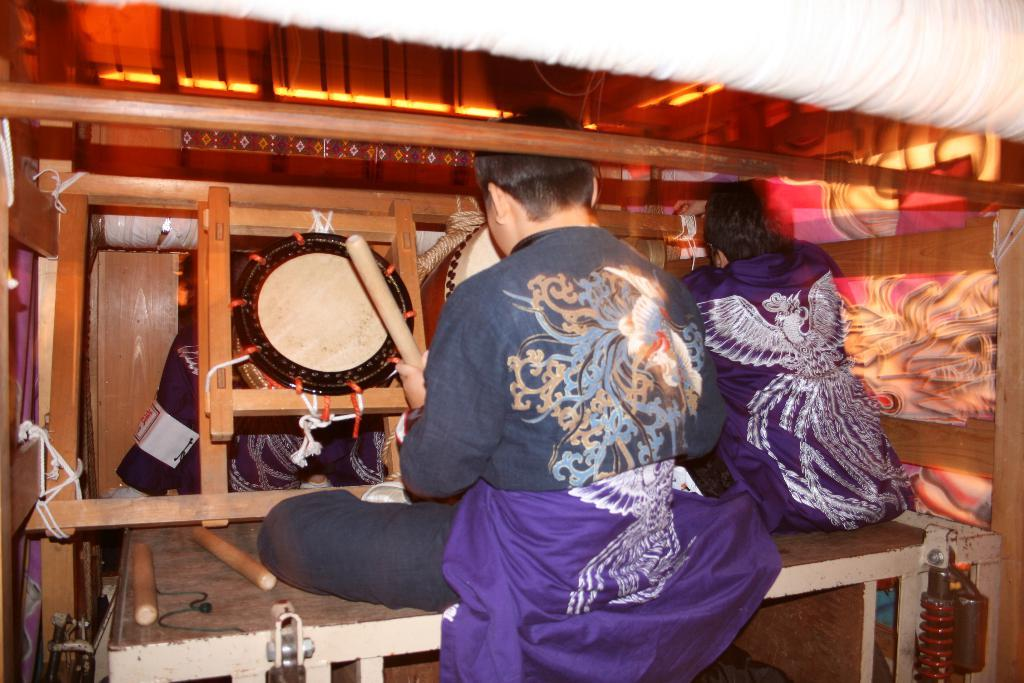What is the person in the image doing? The person is sitting on a bench in the image. What is the person wearing? The person is wearing a blue skirt. What material is in front of the person? There is wood in front of the person. What can be seen on the wall in the image? There is art on the wall in the image. How many minutes does the pig take to cross the low fence in the image? There is no pig or fence present in the image, so this question cannot be answered. 